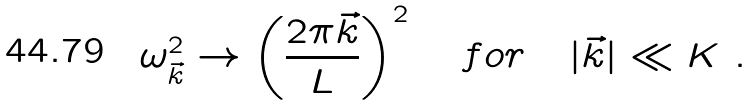Convert formula to latex. <formula><loc_0><loc_0><loc_500><loc_500>\omega _ { \vec { k } } ^ { 2 } \rightarrow \left ( \frac { 2 \pi \vec { k } } { L } \right ) ^ { 2 } \quad f o r \quad | \vec { k } | \ll K \ .</formula> 